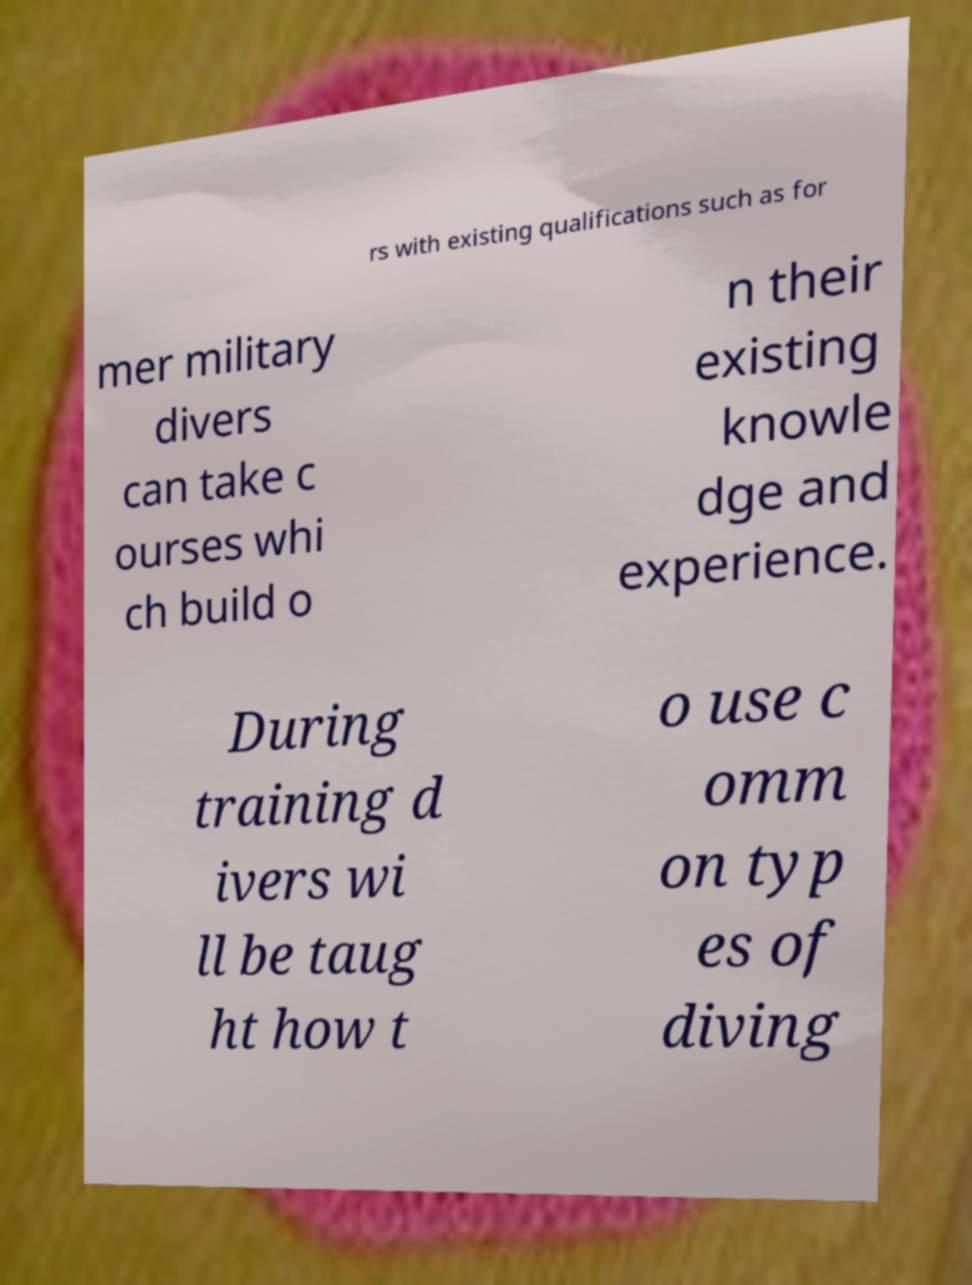What messages or text are displayed in this image? I need them in a readable, typed format. rs with existing qualifications such as for mer military divers can take c ourses whi ch build o n their existing knowle dge and experience. During training d ivers wi ll be taug ht how t o use c omm on typ es of diving 